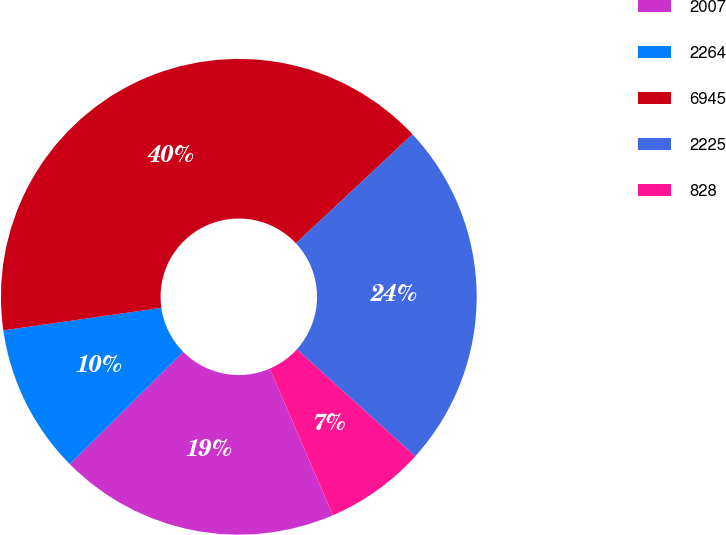Convert chart to OTSL. <chart><loc_0><loc_0><loc_500><loc_500><pie_chart><fcel>2007<fcel>2264<fcel>6945<fcel>2225<fcel>828<nl><fcel>19.05%<fcel>10.17%<fcel>40.29%<fcel>23.67%<fcel>6.82%<nl></chart> 